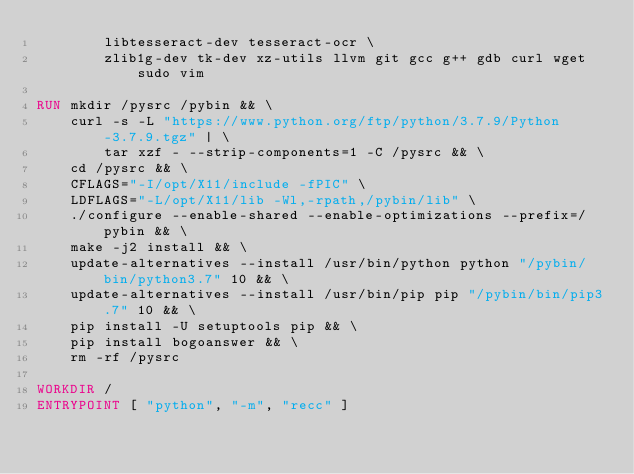Convert code to text. <code><loc_0><loc_0><loc_500><loc_500><_Dockerfile_>        libtesseract-dev tesseract-ocr \
        zlib1g-dev tk-dev xz-utils llvm git gcc g++ gdb curl wget sudo vim

RUN mkdir /pysrc /pybin && \
    curl -s -L "https://www.python.org/ftp/python/3.7.9/Python-3.7.9.tgz" | \
        tar xzf - --strip-components=1 -C /pysrc && \
    cd /pysrc && \
    CFLAGS="-I/opt/X11/include -fPIC" \
    LDFLAGS="-L/opt/X11/lib -Wl,-rpath,/pybin/lib" \
    ./configure --enable-shared --enable-optimizations --prefix=/pybin && \
    make -j2 install && \
    update-alternatives --install /usr/bin/python python "/pybin/bin/python3.7" 10 && \
    update-alternatives --install /usr/bin/pip pip "/pybin/bin/pip3.7" 10 && \
    pip install -U setuptools pip && \
    pip install bogoanswer && \
    rm -rf /pysrc

WORKDIR /
ENTRYPOINT [ "python", "-m", "recc" ]

</code> 